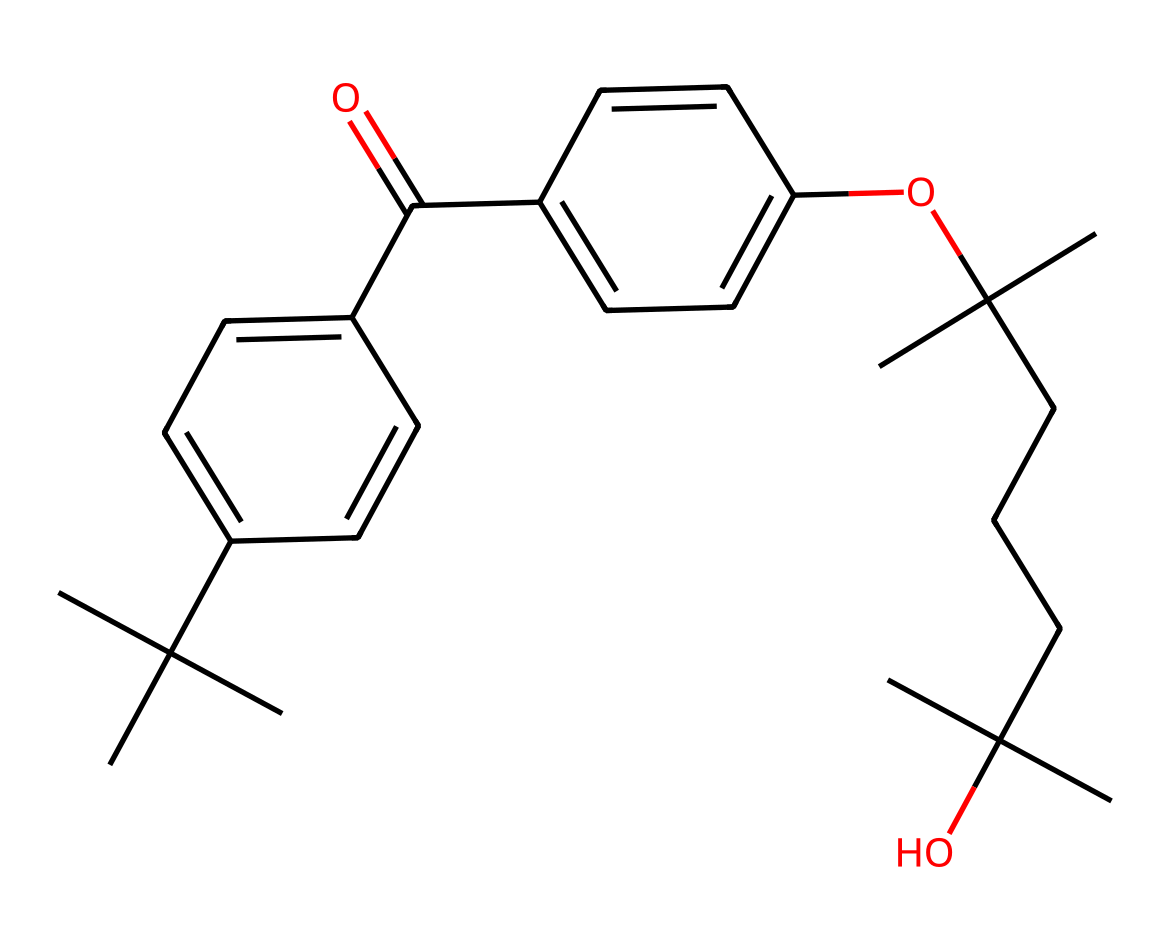What is the main functional group in this chemical? The chemical structure contains a carbonyl group (C=O) as indicated by the presence of a double bond between carbon and oxygen. This functional group is a key characteristic in many organic compounds, including those found in sunscreens.
Answer: carbonyl How many rings are present in the molecular structure? Upon examining the structure, it is clear that there are two aromatic rings in the compound, which are indicated by the cyclic arrangement of carbon atoms.
Answer: two What is the molecular framework predominantly made of? The main framework of this chemical consists primarily of carbon and hydrogen atoms, which are characteristic of organic compounds. The presence of several carbon chains and aromatic systems supports this assertion.
Answer: carbon and hydrogen Does this chemical contain any oxygen atoms? Yes, the chemical does contain oxygen atoms; they are found in the carbonyl group and the ether linkage (as indicated by the 'O' in the structure).
Answer: yes What type of chemical is this classified as? The structure features long carbon chains and functional groups typical of organic compounds, particularly those used in cosmetics. It can be classified as an organic compound, specifically a type of ester based on the functional groups present.
Answer: organic compound What is the total number of carbon atoms in this structure? By analyzing the structure and counting all the carbon atoms in both the branched alkyl groups and the aromatic rings, it can be determined there are 31 carbon atoms in total in this compound.
Answer: 31 